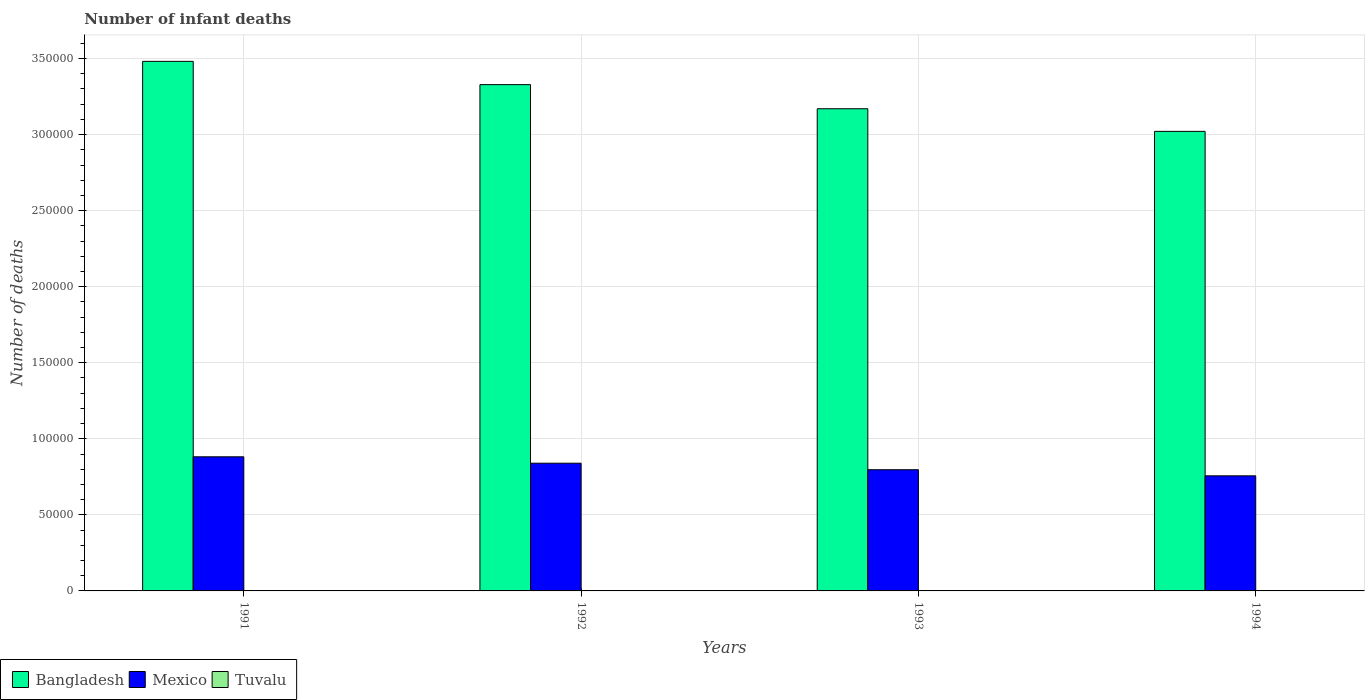How many different coloured bars are there?
Make the answer very short. 3. Are the number of bars per tick equal to the number of legend labels?
Provide a succinct answer. Yes. Are the number of bars on each tick of the X-axis equal?
Provide a short and direct response. Yes. In how many cases, is the number of bars for a given year not equal to the number of legend labels?
Make the answer very short. 0. What is the number of infant deaths in Bangladesh in 1993?
Offer a very short reply. 3.17e+05. Across all years, what is the minimum number of infant deaths in Bangladesh?
Provide a succinct answer. 3.02e+05. In which year was the number of infant deaths in Bangladesh maximum?
Give a very brief answer. 1991. What is the total number of infant deaths in Tuvalu in the graph?
Keep it short and to the point. 40. What is the difference between the number of infant deaths in Bangladesh in 1991 and that in 1993?
Ensure brevity in your answer.  3.12e+04. What is the difference between the number of infant deaths in Tuvalu in 1992 and the number of infant deaths in Bangladesh in 1994?
Provide a succinct answer. -3.02e+05. What is the average number of infant deaths in Mexico per year?
Keep it short and to the point. 8.19e+04. In the year 1994, what is the difference between the number of infant deaths in Mexico and number of infant deaths in Bangladesh?
Ensure brevity in your answer.  -2.26e+05. What is the ratio of the number of infant deaths in Mexico in 1991 to that in 1992?
Provide a short and direct response. 1.05. Is the difference between the number of infant deaths in Mexico in 1991 and 1992 greater than the difference between the number of infant deaths in Bangladesh in 1991 and 1992?
Give a very brief answer. No. What is the difference between the highest and the second highest number of infant deaths in Mexico?
Ensure brevity in your answer.  4217. What is the difference between the highest and the lowest number of infant deaths in Tuvalu?
Your answer should be very brief. 2. What does the 1st bar from the right in 1994 represents?
Provide a succinct answer. Tuvalu. Is it the case that in every year, the sum of the number of infant deaths in Mexico and number of infant deaths in Tuvalu is greater than the number of infant deaths in Bangladesh?
Your answer should be compact. No. What is the difference between two consecutive major ticks on the Y-axis?
Provide a short and direct response. 5.00e+04. Are the values on the major ticks of Y-axis written in scientific E-notation?
Ensure brevity in your answer.  No. Does the graph contain any zero values?
Your answer should be compact. No. What is the title of the graph?
Give a very brief answer. Number of infant deaths. What is the label or title of the X-axis?
Offer a terse response. Years. What is the label or title of the Y-axis?
Give a very brief answer. Number of deaths. What is the Number of deaths in Bangladesh in 1991?
Ensure brevity in your answer.  3.48e+05. What is the Number of deaths of Mexico in 1991?
Keep it short and to the point. 8.82e+04. What is the Number of deaths in Tuvalu in 1991?
Make the answer very short. 11. What is the Number of deaths in Bangladesh in 1992?
Make the answer very short. 3.33e+05. What is the Number of deaths of Mexico in 1992?
Provide a succinct answer. 8.40e+04. What is the Number of deaths in Tuvalu in 1992?
Offer a terse response. 10. What is the Number of deaths in Bangladesh in 1993?
Keep it short and to the point. 3.17e+05. What is the Number of deaths in Mexico in 1993?
Offer a terse response. 7.97e+04. What is the Number of deaths of Bangladesh in 1994?
Your answer should be very brief. 3.02e+05. What is the Number of deaths in Mexico in 1994?
Provide a succinct answer. 7.57e+04. Across all years, what is the maximum Number of deaths of Bangladesh?
Offer a terse response. 3.48e+05. Across all years, what is the maximum Number of deaths in Mexico?
Provide a short and direct response. 8.82e+04. Across all years, what is the minimum Number of deaths of Bangladesh?
Provide a succinct answer. 3.02e+05. Across all years, what is the minimum Number of deaths in Mexico?
Provide a succinct answer. 7.57e+04. Across all years, what is the minimum Number of deaths in Tuvalu?
Make the answer very short. 9. What is the total Number of deaths in Bangladesh in the graph?
Your answer should be compact. 1.30e+06. What is the total Number of deaths of Mexico in the graph?
Ensure brevity in your answer.  3.27e+05. What is the total Number of deaths in Tuvalu in the graph?
Keep it short and to the point. 40. What is the difference between the Number of deaths of Bangladesh in 1991 and that in 1992?
Make the answer very short. 1.53e+04. What is the difference between the Number of deaths in Mexico in 1991 and that in 1992?
Your answer should be very brief. 4217. What is the difference between the Number of deaths of Bangladesh in 1991 and that in 1993?
Your answer should be compact. 3.12e+04. What is the difference between the Number of deaths in Mexico in 1991 and that in 1993?
Give a very brief answer. 8500. What is the difference between the Number of deaths of Bangladesh in 1991 and that in 1994?
Your answer should be very brief. 4.60e+04. What is the difference between the Number of deaths in Mexico in 1991 and that in 1994?
Your answer should be very brief. 1.25e+04. What is the difference between the Number of deaths in Tuvalu in 1991 and that in 1994?
Offer a terse response. 2. What is the difference between the Number of deaths in Bangladesh in 1992 and that in 1993?
Ensure brevity in your answer.  1.58e+04. What is the difference between the Number of deaths in Mexico in 1992 and that in 1993?
Your response must be concise. 4283. What is the difference between the Number of deaths in Bangladesh in 1992 and that in 1994?
Provide a succinct answer. 3.07e+04. What is the difference between the Number of deaths in Mexico in 1992 and that in 1994?
Provide a short and direct response. 8302. What is the difference between the Number of deaths in Bangladesh in 1993 and that in 1994?
Your response must be concise. 1.49e+04. What is the difference between the Number of deaths of Mexico in 1993 and that in 1994?
Ensure brevity in your answer.  4019. What is the difference between the Number of deaths of Bangladesh in 1991 and the Number of deaths of Mexico in 1992?
Offer a terse response. 2.64e+05. What is the difference between the Number of deaths of Bangladesh in 1991 and the Number of deaths of Tuvalu in 1992?
Your response must be concise. 3.48e+05. What is the difference between the Number of deaths in Mexico in 1991 and the Number of deaths in Tuvalu in 1992?
Provide a short and direct response. 8.82e+04. What is the difference between the Number of deaths of Bangladesh in 1991 and the Number of deaths of Mexico in 1993?
Your answer should be very brief. 2.68e+05. What is the difference between the Number of deaths in Bangladesh in 1991 and the Number of deaths in Tuvalu in 1993?
Your response must be concise. 3.48e+05. What is the difference between the Number of deaths in Mexico in 1991 and the Number of deaths in Tuvalu in 1993?
Provide a short and direct response. 8.82e+04. What is the difference between the Number of deaths in Bangladesh in 1991 and the Number of deaths in Mexico in 1994?
Your answer should be compact. 2.73e+05. What is the difference between the Number of deaths in Bangladesh in 1991 and the Number of deaths in Tuvalu in 1994?
Make the answer very short. 3.48e+05. What is the difference between the Number of deaths in Mexico in 1991 and the Number of deaths in Tuvalu in 1994?
Keep it short and to the point. 8.82e+04. What is the difference between the Number of deaths of Bangladesh in 1992 and the Number of deaths of Mexico in 1993?
Ensure brevity in your answer.  2.53e+05. What is the difference between the Number of deaths of Bangladesh in 1992 and the Number of deaths of Tuvalu in 1993?
Your answer should be very brief. 3.33e+05. What is the difference between the Number of deaths of Mexico in 1992 and the Number of deaths of Tuvalu in 1993?
Offer a very short reply. 8.39e+04. What is the difference between the Number of deaths in Bangladesh in 1992 and the Number of deaths in Mexico in 1994?
Give a very brief answer. 2.57e+05. What is the difference between the Number of deaths of Bangladesh in 1992 and the Number of deaths of Tuvalu in 1994?
Ensure brevity in your answer.  3.33e+05. What is the difference between the Number of deaths in Mexico in 1992 and the Number of deaths in Tuvalu in 1994?
Keep it short and to the point. 8.40e+04. What is the difference between the Number of deaths in Bangladesh in 1993 and the Number of deaths in Mexico in 1994?
Keep it short and to the point. 2.41e+05. What is the difference between the Number of deaths in Bangladesh in 1993 and the Number of deaths in Tuvalu in 1994?
Provide a succinct answer. 3.17e+05. What is the difference between the Number of deaths in Mexico in 1993 and the Number of deaths in Tuvalu in 1994?
Provide a succinct answer. 7.97e+04. What is the average Number of deaths in Bangladesh per year?
Make the answer very short. 3.25e+05. What is the average Number of deaths of Mexico per year?
Your answer should be compact. 8.19e+04. What is the average Number of deaths in Tuvalu per year?
Your response must be concise. 10. In the year 1991, what is the difference between the Number of deaths in Bangladesh and Number of deaths in Mexico?
Make the answer very short. 2.60e+05. In the year 1991, what is the difference between the Number of deaths of Bangladesh and Number of deaths of Tuvalu?
Give a very brief answer. 3.48e+05. In the year 1991, what is the difference between the Number of deaths in Mexico and Number of deaths in Tuvalu?
Make the answer very short. 8.82e+04. In the year 1992, what is the difference between the Number of deaths in Bangladesh and Number of deaths in Mexico?
Provide a succinct answer. 2.49e+05. In the year 1992, what is the difference between the Number of deaths of Bangladesh and Number of deaths of Tuvalu?
Keep it short and to the point. 3.33e+05. In the year 1992, what is the difference between the Number of deaths in Mexico and Number of deaths in Tuvalu?
Offer a terse response. 8.39e+04. In the year 1993, what is the difference between the Number of deaths in Bangladesh and Number of deaths in Mexico?
Your response must be concise. 2.37e+05. In the year 1993, what is the difference between the Number of deaths of Bangladesh and Number of deaths of Tuvalu?
Your answer should be compact. 3.17e+05. In the year 1993, what is the difference between the Number of deaths in Mexico and Number of deaths in Tuvalu?
Offer a terse response. 7.97e+04. In the year 1994, what is the difference between the Number of deaths in Bangladesh and Number of deaths in Mexico?
Offer a very short reply. 2.26e+05. In the year 1994, what is the difference between the Number of deaths of Bangladesh and Number of deaths of Tuvalu?
Give a very brief answer. 3.02e+05. In the year 1994, what is the difference between the Number of deaths in Mexico and Number of deaths in Tuvalu?
Provide a short and direct response. 7.56e+04. What is the ratio of the Number of deaths in Bangladesh in 1991 to that in 1992?
Ensure brevity in your answer.  1.05. What is the ratio of the Number of deaths of Mexico in 1991 to that in 1992?
Your answer should be compact. 1.05. What is the ratio of the Number of deaths in Tuvalu in 1991 to that in 1992?
Give a very brief answer. 1.1. What is the ratio of the Number of deaths in Bangladesh in 1991 to that in 1993?
Make the answer very short. 1.1. What is the ratio of the Number of deaths in Mexico in 1991 to that in 1993?
Your answer should be very brief. 1.11. What is the ratio of the Number of deaths of Bangladesh in 1991 to that in 1994?
Give a very brief answer. 1.15. What is the ratio of the Number of deaths in Mexico in 1991 to that in 1994?
Ensure brevity in your answer.  1.17. What is the ratio of the Number of deaths of Tuvalu in 1991 to that in 1994?
Offer a very short reply. 1.22. What is the ratio of the Number of deaths of Bangladesh in 1992 to that in 1993?
Make the answer very short. 1.05. What is the ratio of the Number of deaths of Mexico in 1992 to that in 1993?
Keep it short and to the point. 1.05. What is the ratio of the Number of deaths in Bangladesh in 1992 to that in 1994?
Provide a succinct answer. 1.1. What is the ratio of the Number of deaths in Mexico in 1992 to that in 1994?
Offer a very short reply. 1.11. What is the ratio of the Number of deaths in Bangladesh in 1993 to that in 1994?
Provide a succinct answer. 1.05. What is the ratio of the Number of deaths in Mexico in 1993 to that in 1994?
Give a very brief answer. 1.05. What is the ratio of the Number of deaths of Tuvalu in 1993 to that in 1994?
Offer a terse response. 1.11. What is the difference between the highest and the second highest Number of deaths of Bangladesh?
Keep it short and to the point. 1.53e+04. What is the difference between the highest and the second highest Number of deaths in Mexico?
Provide a succinct answer. 4217. What is the difference between the highest and the second highest Number of deaths in Tuvalu?
Your response must be concise. 1. What is the difference between the highest and the lowest Number of deaths of Bangladesh?
Provide a short and direct response. 4.60e+04. What is the difference between the highest and the lowest Number of deaths in Mexico?
Your answer should be very brief. 1.25e+04. What is the difference between the highest and the lowest Number of deaths of Tuvalu?
Offer a terse response. 2. 